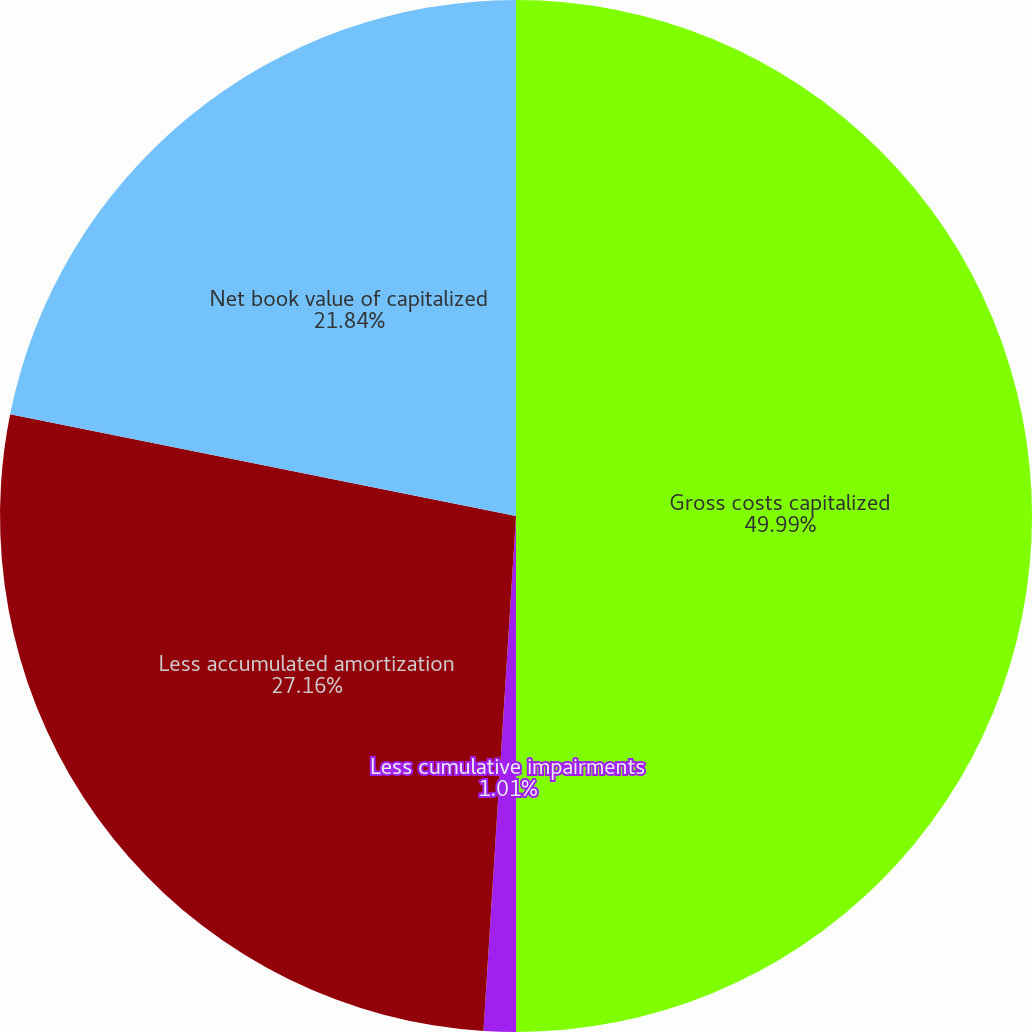Convert chart to OTSL. <chart><loc_0><loc_0><loc_500><loc_500><pie_chart><fcel>Gross costs capitalized<fcel>Less cumulative impairments<fcel>Less accumulated amortization<fcel>Net book value of capitalized<nl><fcel>50.0%<fcel>1.01%<fcel>27.16%<fcel>21.84%<nl></chart> 